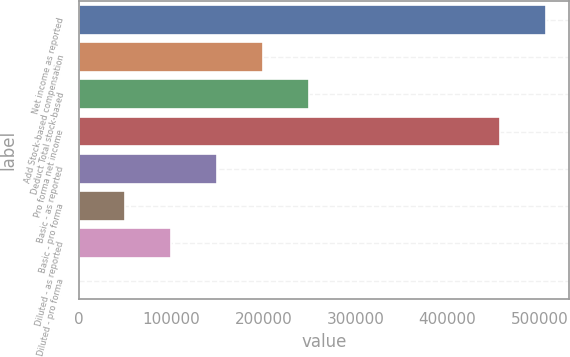Convert chart. <chart><loc_0><loc_0><loc_500><loc_500><bar_chart><fcel>Net income as reported<fcel>Add Stock-based compensation<fcel>Deduct Total stock-based<fcel>Pro forma net income<fcel>Basic - as reported<fcel>Basic - pro forma<fcel>Diluted - as reported<fcel>Diluted - pro forma<nl><fcel>506788<fcel>199679<fcel>249599<fcel>456869<fcel>149760<fcel>49921.4<fcel>99840.7<fcel>2.13<nl></chart> 